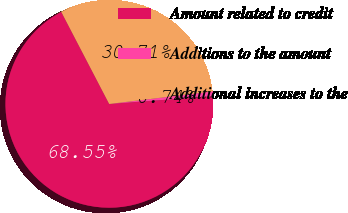Convert chart. <chart><loc_0><loc_0><loc_500><loc_500><pie_chart><fcel>Amount related to credit<fcel>Additions to the amount<fcel>Additional increases to the<nl><fcel>68.55%<fcel>0.74%<fcel>30.71%<nl></chart> 